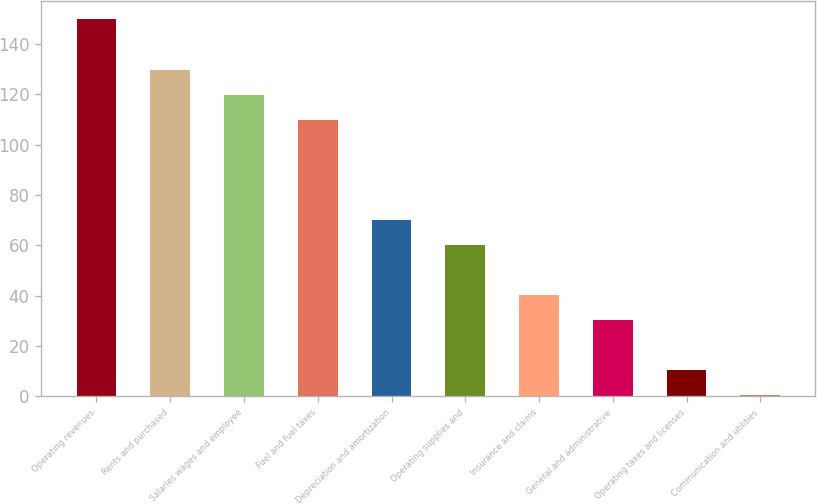Convert chart to OTSL. <chart><loc_0><loc_0><loc_500><loc_500><bar_chart><fcel>Operating revenues<fcel>Rents and purchased<fcel>Salaries wages and employee<fcel>Fuel and fuel taxes<fcel>Depreciation and amortization<fcel>Operating supplies and<fcel>Insurance and claims<fcel>General and administrative<fcel>Operating taxes and licenses<fcel>Communication and utilities<nl><fcel>149.8<fcel>129.88<fcel>119.92<fcel>109.96<fcel>70.12<fcel>60.16<fcel>40.24<fcel>30.28<fcel>10.36<fcel>0.4<nl></chart> 